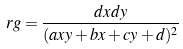Convert formula to latex. <formula><loc_0><loc_0><loc_500><loc_500>\ r g = \frac { d x d y } { ( a x y + b x + c y + d ) ^ { 2 } }</formula> 